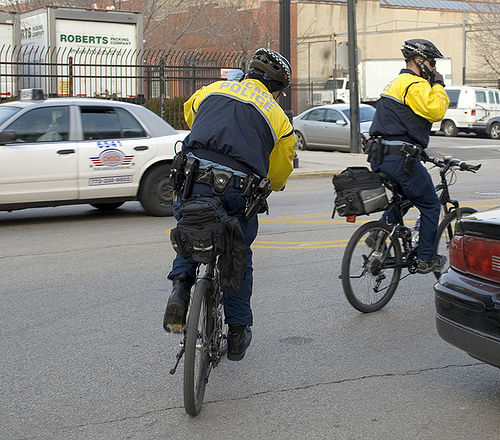Please extract the text content from this image. ROBERTS 6541 POLICE 